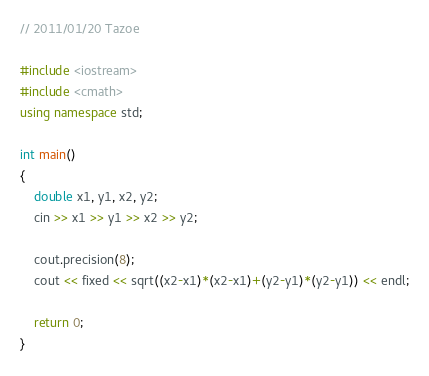Convert code to text. <code><loc_0><loc_0><loc_500><loc_500><_C++_>// 2011/01/20 Tazoe

#include <iostream>
#include <cmath>
using namespace std;

int main()
{
	double x1, y1, x2, y2;
	cin >> x1 >> y1 >> x2 >> y2;

	cout.precision(8);
	cout << fixed << sqrt((x2-x1)*(x2-x1)+(y2-y1)*(y2-y1)) << endl;

	return 0;
}</code> 